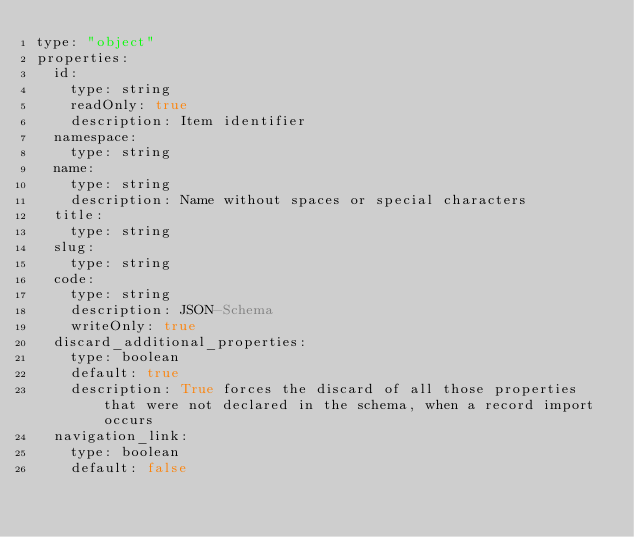<code> <loc_0><loc_0><loc_500><loc_500><_YAML_>type: "object"
properties:
  id:
    type: string
    readOnly: true
    description: Item identifier
  namespace:
    type: string
  name:
    type: string
    description: Name without spaces or special characters
  title:
    type: string
  slug:
    type: string
  code:
    type: string
    description: JSON-Schema
    writeOnly: true
  discard_additional_properties:
    type: boolean
    default: true
    description: True forces the discard of all those properties that were not declared in the schema, when a record import occurs
  navigation_link:
    type: boolean
    default: false
</code> 